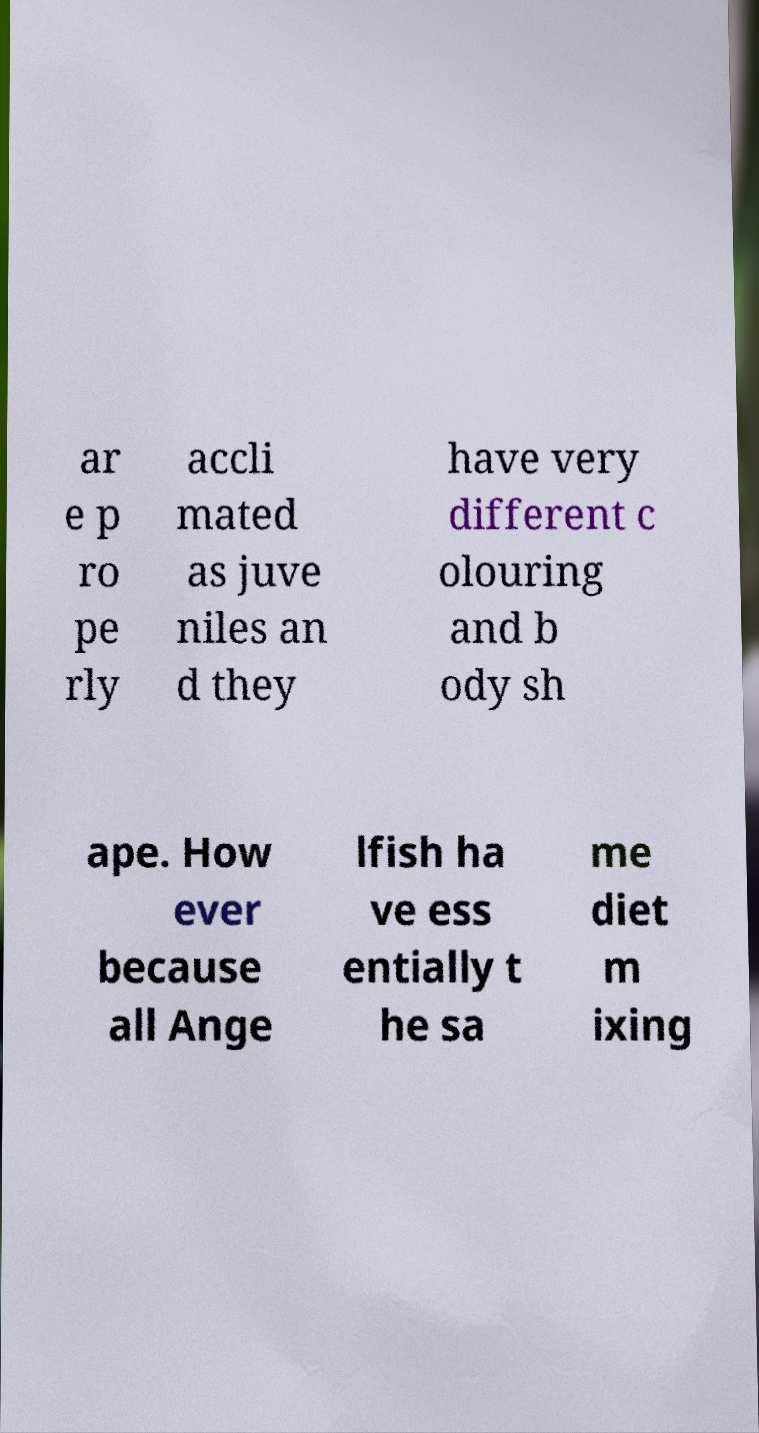I need the written content from this picture converted into text. Can you do that? ar e p ro pe rly accli mated as juve niles an d they have very different c olouring and b ody sh ape. How ever because all Ange lfish ha ve ess entially t he sa me diet m ixing 